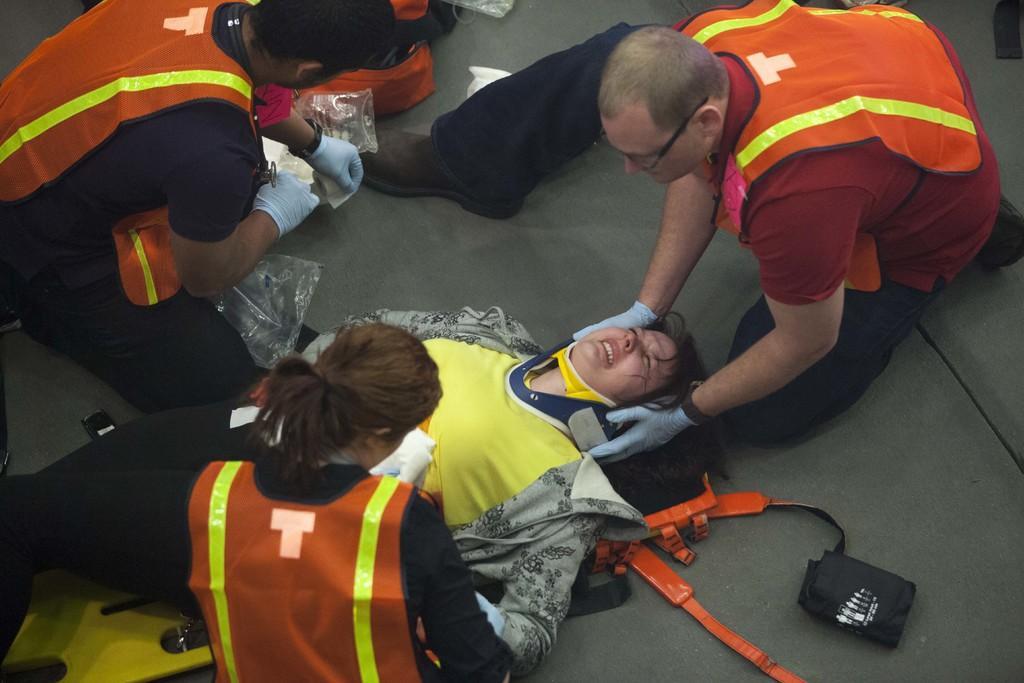Can you describe this image briefly? In this image in the center there is one woman who is laying on a stretcher, and she is crying and there are some people. One person is wearing gloves and holding something, at the bottom there is floor. On the floor there are some bags and plastic covers. 